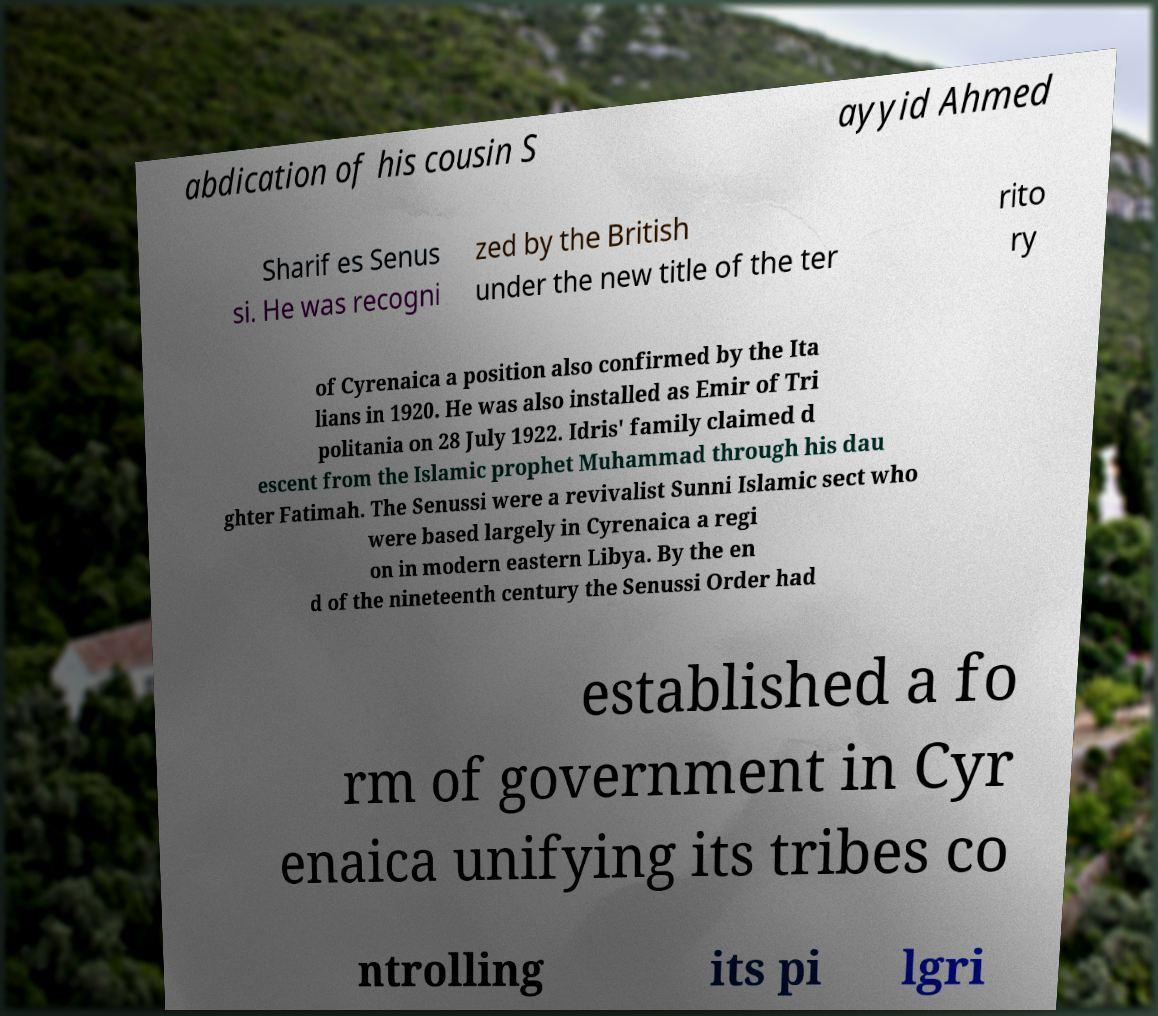Can you accurately transcribe the text from the provided image for me? abdication of his cousin S ayyid Ahmed Sharif es Senus si. He was recogni zed by the British under the new title of the ter rito ry of Cyrenaica a position also confirmed by the Ita lians in 1920. He was also installed as Emir of Tri politania on 28 July 1922. Idris' family claimed d escent from the Islamic prophet Muhammad through his dau ghter Fatimah. The Senussi were a revivalist Sunni Islamic sect who were based largely in Cyrenaica a regi on in modern eastern Libya. By the en d of the nineteenth century the Senussi Order had established a fo rm of government in Cyr enaica unifying its tribes co ntrolling its pi lgri 